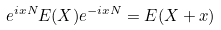<formula> <loc_0><loc_0><loc_500><loc_500>e ^ { i x N } E ( X ) e ^ { - i x N } = E ( X + x )</formula> 